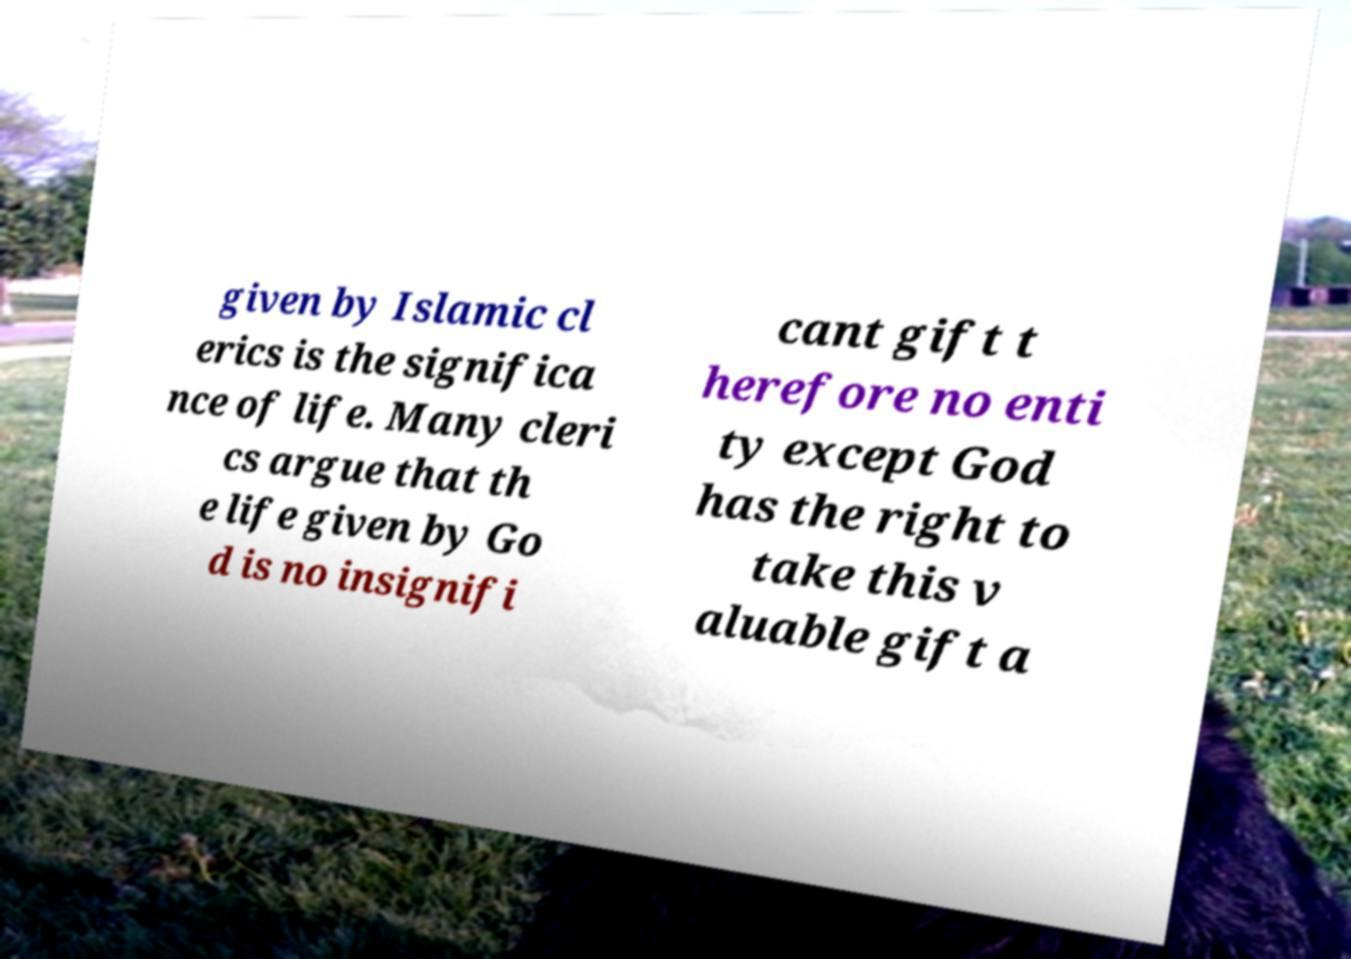There's text embedded in this image that I need extracted. Can you transcribe it verbatim? given by Islamic cl erics is the significa nce of life. Many cleri cs argue that th e life given by Go d is no insignifi cant gift t herefore no enti ty except God has the right to take this v aluable gift a 